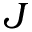<formula> <loc_0><loc_0><loc_500><loc_500>J</formula> 